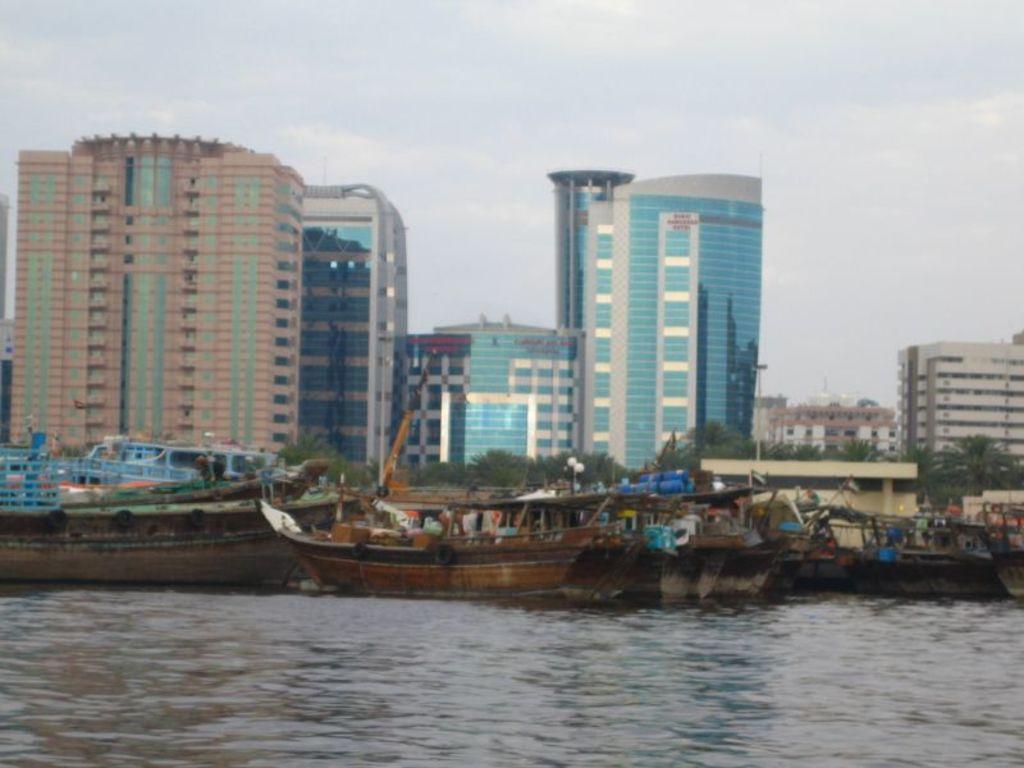Describe this image in one or two sentences. In this image there are buildings and trees, in front of the image there are boats on the water. 